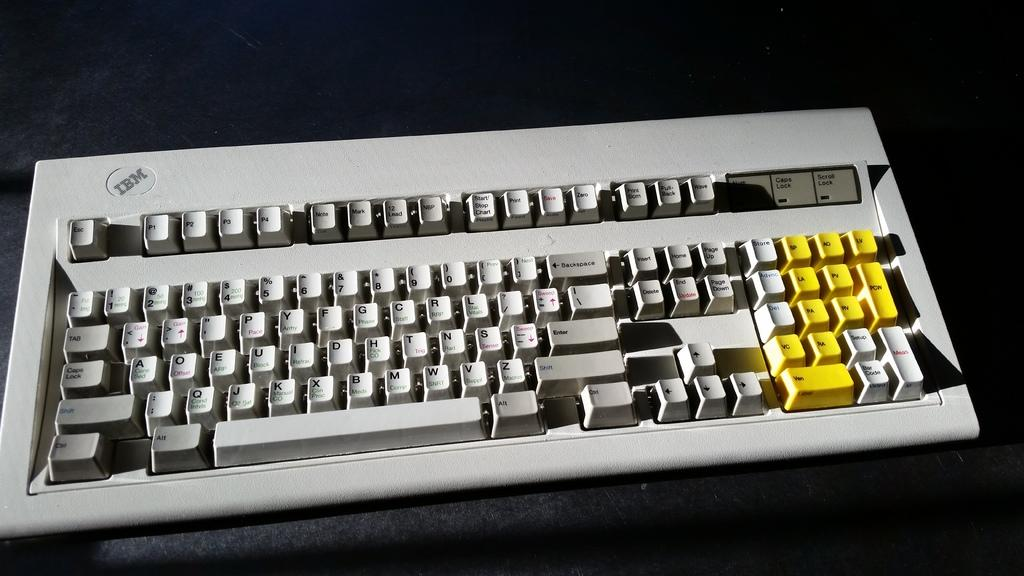<image>
Share a concise interpretation of the image provided. Photo of gray IBM keyboard of uncertain vintage 